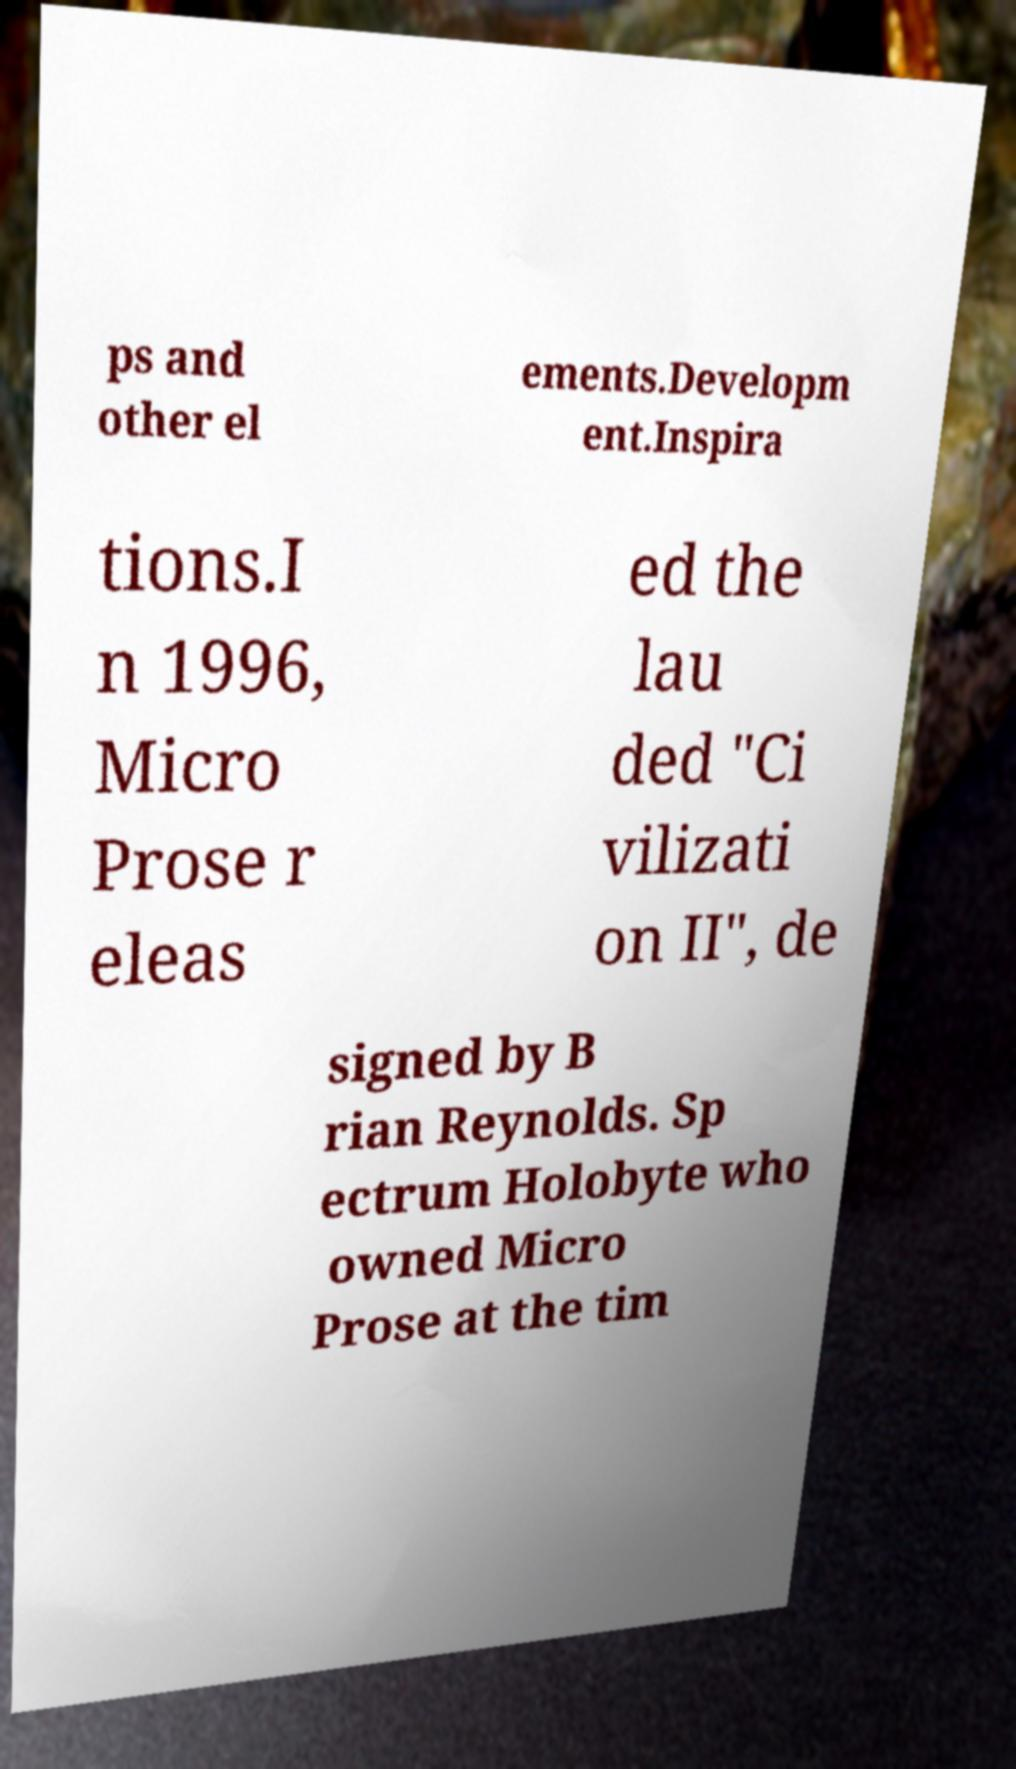What messages or text are displayed in this image? I need them in a readable, typed format. ps and other el ements.Developm ent.Inspira tions.I n 1996, Micro Prose r eleas ed the lau ded "Ci vilizati on II", de signed by B rian Reynolds. Sp ectrum Holobyte who owned Micro Prose at the tim 